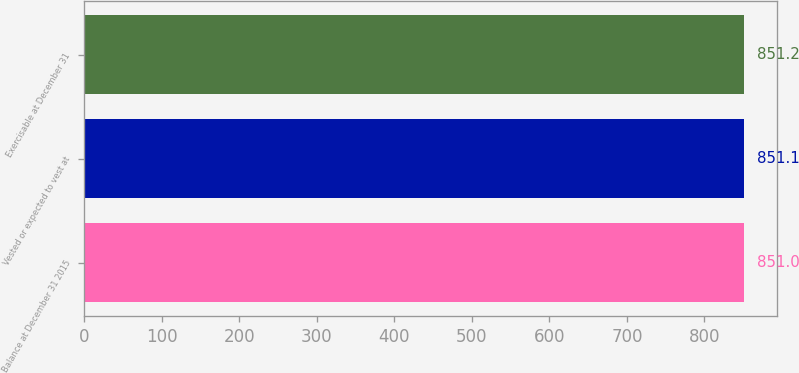<chart> <loc_0><loc_0><loc_500><loc_500><bar_chart><fcel>Balance at December 31 2015<fcel>Vested or expected to vest at<fcel>Exercisable at December 31<nl><fcel>851<fcel>851.1<fcel>851.2<nl></chart> 